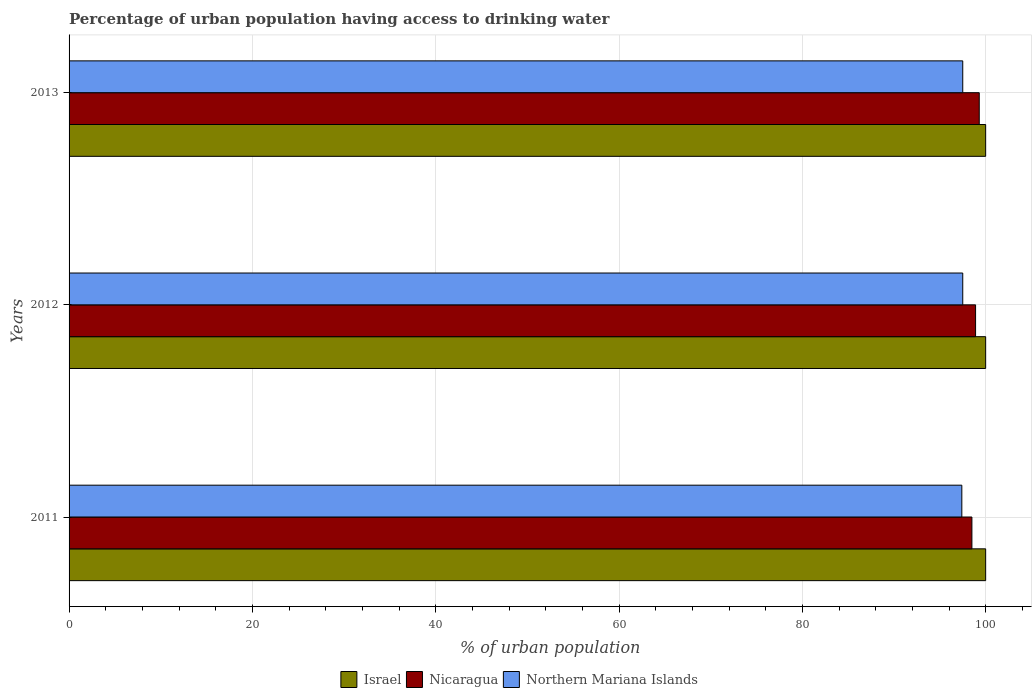How many groups of bars are there?
Your response must be concise. 3. Are the number of bars on each tick of the Y-axis equal?
Make the answer very short. Yes. How many bars are there on the 2nd tick from the top?
Provide a short and direct response. 3. How many bars are there on the 3rd tick from the bottom?
Keep it short and to the point. 3. What is the label of the 1st group of bars from the top?
Ensure brevity in your answer.  2013. In how many cases, is the number of bars for a given year not equal to the number of legend labels?
Your response must be concise. 0. What is the percentage of urban population having access to drinking water in Nicaragua in 2011?
Provide a succinct answer. 98.5. Across all years, what is the maximum percentage of urban population having access to drinking water in Northern Mariana Islands?
Provide a short and direct response. 97.5. Across all years, what is the minimum percentage of urban population having access to drinking water in Israel?
Offer a terse response. 100. What is the total percentage of urban population having access to drinking water in Israel in the graph?
Keep it short and to the point. 300. What is the difference between the percentage of urban population having access to drinking water in Northern Mariana Islands in 2011 and that in 2013?
Keep it short and to the point. -0.1. What is the difference between the percentage of urban population having access to drinking water in Israel in 2013 and the percentage of urban population having access to drinking water in Northern Mariana Islands in 2012?
Offer a terse response. 2.5. What is the average percentage of urban population having access to drinking water in Nicaragua per year?
Your answer should be very brief. 98.9. In the year 2011, what is the difference between the percentage of urban population having access to drinking water in Israel and percentage of urban population having access to drinking water in Northern Mariana Islands?
Ensure brevity in your answer.  2.6. In how many years, is the percentage of urban population having access to drinking water in Nicaragua greater than 76 %?
Make the answer very short. 3. What is the ratio of the percentage of urban population having access to drinking water in Northern Mariana Islands in 2012 to that in 2013?
Your answer should be compact. 1. Is the percentage of urban population having access to drinking water in Northern Mariana Islands in 2012 less than that in 2013?
Make the answer very short. No. Is the difference between the percentage of urban population having access to drinking water in Israel in 2011 and 2012 greater than the difference between the percentage of urban population having access to drinking water in Northern Mariana Islands in 2011 and 2012?
Your answer should be very brief. Yes. What is the difference between the highest and the second highest percentage of urban population having access to drinking water in Israel?
Provide a short and direct response. 0. What is the difference between the highest and the lowest percentage of urban population having access to drinking water in Northern Mariana Islands?
Make the answer very short. 0.1. In how many years, is the percentage of urban population having access to drinking water in Northern Mariana Islands greater than the average percentage of urban population having access to drinking water in Northern Mariana Islands taken over all years?
Make the answer very short. 2. What does the 1st bar from the top in 2012 represents?
Ensure brevity in your answer.  Northern Mariana Islands. How many bars are there?
Make the answer very short. 9. Are all the bars in the graph horizontal?
Offer a terse response. Yes. How many years are there in the graph?
Provide a succinct answer. 3. Does the graph contain any zero values?
Your response must be concise. No. Where does the legend appear in the graph?
Keep it short and to the point. Bottom center. How many legend labels are there?
Your answer should be compact. 3. What is the title of the graph?
Offer a terse response. Percentage of urban population having access to drinking water. Does "Somalia" appear as one of the legend labels in the graph?
Your answer should be compact. No. What is the label or title of the X-axis?
Your response must be concise. % of urban population. What is the % of urban population in Nicaragua in 2011?
Your answer should be very brief. 98.5. What is the % of urban population in Northern Mariana Islands in 2011?
Your answer should be very brief. 97.4. What is the % of urban population of Nicaragua in 2012?
Offer a terse response. 98.9. What is the % of urban population of Northern Mariana Islands in 2012?
Make the answer very short. 97.5. What is the % of urban population of Nicaragua in 2013?
Ensure brevity in your answer.  99.3. What is the % of urban population of Northern Mariana Islands in 2013?
Give a very brief answer. 97.5. Across all years, what is the maximum % of urban population in Israel?
Your answer should be compact. 100. Across all years, what is the maximum % of urban population in Nicaragua?
Offer a terse response. 99.3. Across all years, what is the maximum % of urban population in Northern Mariana Islands?
Provide a succinct answer. 97.5. Across all years, what is the minimum % of urban population of Nicaragua?
Ensure brevity in your answer.  98.5. Across all years, what is the minimum % of urban population of Northern Mariana Islands?
Offer a very short reply. 97.4. What is the total % of urban population in Israel in the graph?
Your answer should be very brief. 300. What is the total % of urban population of Nicaragua in the graph?
Give a very brief answer. 296.7. What is the total % of urban population of Northern Mariana Islands in the graph?
Ensure brevity in your answer.  292.4. What is the difference between the % of urban population in Nicaragua in 2011 and that in 2012?
Provide a short and direct response. -0.4. What is the difference between the % of urban population in Northern Mariana Islands in 2011 and that in 2012?
Keep it short and to the point. -0.1. What is the difference between the % of urban population in Israel in 2011 and that in 2013?
Keep it short and to the point. 0. What is the difference between the % of urban population in Nicaragua in 2011 and that in 2013?
Provide a succinct answer. -0.8. What is the difference between the % of urban population in Israel in 2012 and that in 2013?
Provide a succinct answer. 0. What is the difference between the % of urban population of Israel in 2011 and the % of urban population of Northern Mariana Islands in 2012?
Your answer should be very brief. 2.5. What is the difference between the % of urban population in Nicaragua in 2011 and the % of urban population in Northern Mariana Islands in 2012?
Offer a very short reply. 1. What is the difference between the % of urban population in Israel in 2011 and the % of urban population in Nicaragua in 2013?
Give a very brief answer. 0.7. What is the difference between the % of urban population of Israel in 2011 and the % of urban population of Northern Mariana Islands in 2013?
Your answer should be very brief. 2.5. What is the difference between the % of urban population of Nicaragua in 2011 and the % of urban population of Northern Mariana Islands in 2013?
Offer a terse response. 1. What is the difference between the % of urban population of Israel in 2012 and the % of urban population of Nicaragua in 2013?
Offer a terse response. 0.7. What is the average % of urban population in Israel per year?
Make the answer very short. 100. What is the average % of urban population of Nicaragua per year?
Your response must be concise. 98.9. What is the average % of urban population in Northern Mariana Islands per year?
Provide a succinct answer. 97.47. In the year 2011, what is the difference between the % of urban population in Israel and % of urban population in Nicaragua?
Ensure brevity in your answer.  1.5. In the year 2011, what is the difference between the % of urban population of Israel and % of urban population of Northern Mariana Islands?
Your answer should be compact. 2.6. In the year 2013, what is the difference between the % of urban population in Israel and % of urban population in Nicaragua?
Your answer should be compact. 0.7. In the year 2013, what is the difference between the % of urban population of Israel and % of urban population of Northern Mariana Islands?
Your response must be concise. 2.5. What is the ratio of the % of urban population of Israel in 2011 to that in 2012?
Provide a short and direct response. 1. What is the ratio of the % of urban population of Northern Mariana Islands in 2011 to that in 2012?
Keep it short and to the point. 1. What is the ratio of the % of urban population of Israel in 2012 to that in 2013?
Offer a terse response. 1. What is the ratio of the % of urban population of Nicaragua in 2012 to that in 2013?
Give a very brief answer. 1. What is the difference between the highest and the second highest % of urban population of Nicaragua?
Your answer should be very brief. 0.4. What is the difference between the highest and the lowest % of urban population of Nicaragua?
Offer a terse response. 0.8. What is the difference between the highest and the lowest % of urban population of Northern Mariana Islands?
Keep it short and to the point. 0.1. 